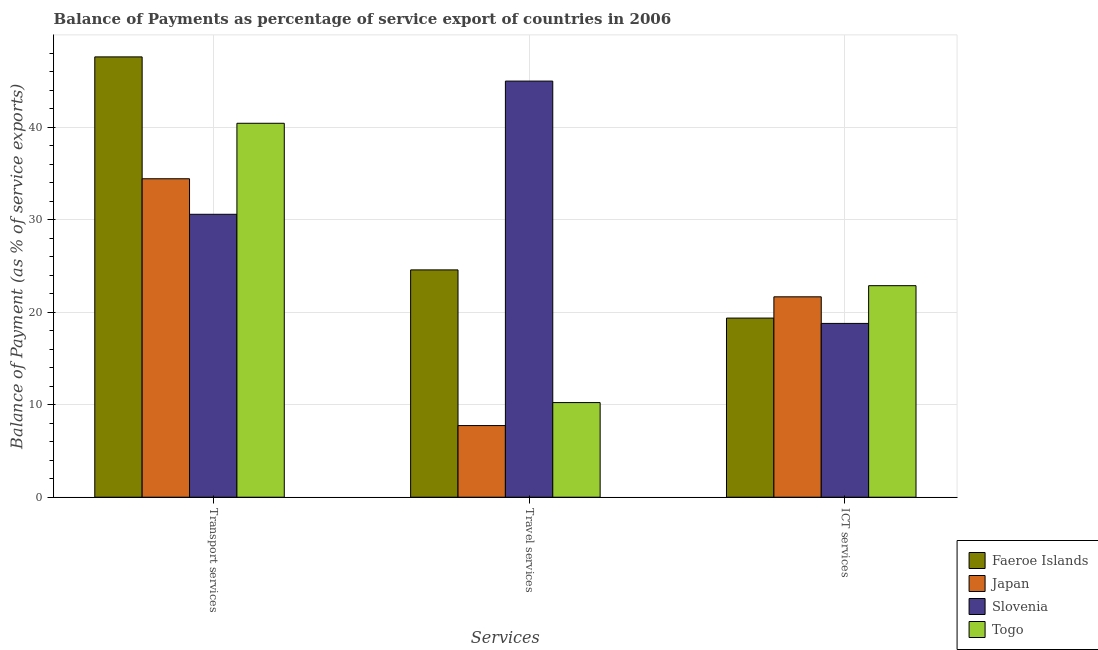How many groups of bars are there?
Your response must be concise. 3. Are the number of bars per tick equal to the number of legend labels?
Your answer should be compact. Yes. How many bars are there on the 1st tick from the left?
Keep it short and to the point. 4. How many bars are there on the 1st tick from the right?
Give a very brief answer. 4. What is the label of the 1st group of bars from the left?
Provide a succinct answer. Transport services. What is the balance of payment of ict services in Slovenia?
Your answer should be compact. 18.79. Across all countries, what is the maximum balance of payment of travel services?
Your answer should be very brief. 44.99. Across all countries, what is the minimum balance of payment of transport services?
Offer a very short reply. 30.59. In which country was the balance of payment of transport services maximum?
Your answer should be very brief. Faeroe Islands. What is the total balance of payment of travel services in the graph?
Give a very brief answer. 87.54. What is the difference between the balance of payment of ict services in Faeroe Islands and that in Slovenia?
Offer a terse response. 0.58. What is the difference between the balance of payment of travel services in Slovenia and the balance of payment of transport services in Japan?
Ensure brevity in your answer.  10.56. What is the average balance of payment of ict services per country?
Provide a short and direct response. 20.67. What is the difference between the balance of payment of ict services and balance of payment of transport services in Japan?
Your answer should be compact. -12.76. In how many countries, is the balance of payment of transport services greater than 36 %?
Your response must be concise. 2. What is the ratio of the balance of payment of travel services in Faeroe Islands to that in Slovenia?
Ensure brevity in your answer.  0.55. What is the difference between the highest and the second highest balance of payment of ict services?
Provide a short and direct response. 1.2. What is the difference between the highest and the lowest balance of payment of transport services?
Offer a terse response. 17.02. In how many countries, is the balance of payment of travel services greater than the average balance of payment of travel services taken over all countries?
Provide a succinct answer. 2. What does the 1st bar from the left in Travel services represents?
Your answer should be very brief. Faeroe Islands. What does the 4th bar from the right in Transport services represents?
Make the answer very short. Faeroe Islands. Are all the bars in the graph horizontal?
Give a very brief answer. No. What is the difference between two consecutive major ticks on the Y-axis?
Make the answer very short. 10. Does the graph contain any zero values?
Offer a terse response. No. Does the graph contain grids?
Offer a terse response. Yes. What is the title of the graph?
Provide a succinct answer. Balance of Payments as percentage of service export of countries in 2006. What is the label or title of the X-axis?
Your answer should be compact. Services. What is the label or title of the Y-axis?
Provide a succinct answer. Balance of Payment (as % of service exports). What is the Balance of Payment (as % of service exports) in Faeroe Islands in Transport services?
Provide a succinct answer. 47.61. What is the Balance of Payment (as % of service exports) in Japan in Transport services?
Provide a succinct answer. 34.43. What is the Balance of Payment (as % of service exports) of Slovenia in Transport services?
Give a very brief answer. 30.59. What is the Balance of Payment (as % of service exports) of Togo in Transport services?
Ensure brevity in your answer.  40.43. What is the Balance of Payment (as % of service exports) of Faeroe Islands in Travel services?
Your answer should be very brief. 24.58. What is the Balance of Payment (as % of service exports) in Japan in Travel services?
Your answer should be very brief. 7.75. What is the Balance of Payment (as % of service exports) in Slovenia in Travel services?
Your answer should be very brief. 44.99. What is the Balance of Payment (as % of service exports) in Togo in Travel services?
Your answer should be very brief. 10.23. What is the Balance of Payment (as % of service exports) of Faeroe Islands in ICT services?
Keep it short and to the point. 19.37. What is the Balance of Payment (as % of service exports) of Japan in ICT services?
Your answer should be very brief. 21.67. What is the Balance of Payment (as % of service exports) of Slovenia in ICT services?
Offer a very short reply. 18.79. What is the Balance of Payment (as % of service exports) of Togo in ICT services?
Keep it short and to the point. 22.87. Across all Services, what is the maximum Balance of Payment (as % of service exports) in Faeroe Islands?
Provide a short and direct response. 47.61. Across all Services, what is the maximum Balance of Payment (as % of service exports) of Japan?
Provide a short and direct response. 34.43. Across all Services, what is the maximum Balance of Payment (as % of service exports) of Slovenia?
Keep it short and to the point. 44.99. Across all Services, what is the maximum Balance of Payment (as % of service exports) of Togo?
Make the answer very short. 40.43. Across all Services, what is the minimum Balance of Payment (as % of service exports) of Faeroe Islands?
Your response must be concise. 19.37. Across all Services, what is the minimum Balance of Payment (as % of service exports) in Japan?
Your response must be concise. 7.75. Across all Services, what is the minimum Balance of Payment (as % of service exports) of Slovenia?
Your response must be concise. 18.79. Across all Services, what is the minimum Balance of Payment (as % of service exports) of Togo?
Your response must be concise. 10.23. What is the total Balance of Payment (as % of service exports) of Faeroe Islands in the graph?
Provide a short and direct response. 91.55. What is the total Balance of Payment (as % of service exports) of Japan in the graph?
Your answer should be very brief. 63.84. What is the total Balance of Payment (as % of service exports) of Slovenia in the graph?
Offer a very short reply. 94.37. What is the total Balance of Payment (as % of service exports) in Togo in the graph?
Provide a succinct answer. 73.53. What is the difference between the Balance of Payment (as % of service exports) in Faeroe Islands in Transport services and that in Travel services?
Keep it short and to the point. 23.03. What is the difference between the Balance of Payment (as % of service exports) in Japan in Transport services and that in Travel services?
Your response must be concise. 26.68. What is the difference between the Balance of Payment (as % of service exports) in Slovenia in Transport services and that in Travel services?
Your response must be concise. -14.4. What is the difference between the Balance of Payment (as % of service exports) of Togo in Transport services and that in Travel services?
Your answer should be very brief. 30.2. What is the difference between the Balance of Payment (as % of service exports) of Faeroe Islands in Transport services and that in ICT services?
Your answer should be very brief. 28.24. What is the difference between the Balance of Payment (as % of service exports) of Japan in Transport services and that in ICT services?
Ensure brevity in your answer.  12.76. What is the difference between the Balance of Payment (as % of service exports) of Slovenia in Transport services and that in ICT services?
Your answer should be very brief. 11.8. What is the difference between the Balance of Payment (as % of service exports) in Togo in Transport services and that in ICT services?
Your answer should be very brief. 17.56. What is the difference between the Balance of Payment (as % of service exports) in Faeroe Islands in Travel services and that in ICT services?
Provide a succinct answer. 5.21. What is the difference between the Balance of Payment (as % of service exports) of Japan in Travel services and that in ICT services?
Offer a very short reply. -13.92. What is the difference between the Balance of Payment (as % of service exports) of Slovenia in Travel services and that in ICT services?
Provide a succinct answer. 26.2. What is the difference between the Balance of Payment (as % of service exports) of Togo in Travel services and that in ICT services?
Your answer should be very brief. -12.64. What is the difference between the Balance of Payment (as % of service exports) of Faeroe Islands in Transport services and the Balance of Payment (as % of service exports) of Japan in Travel services?
Make the answer very short. 39.86. What is the difference between the Balance of Payment (as % of service exports) of Faeroe Islands in Transport services and the Balance of Payment (as % of service exports) of Slovenia in Travel services?
Your response must be concise. 2.62. What is the difference between the Balance of Payment (as % of service exports) in Faeroe Islands in Transport services and the Balance of Payment (as % of service exports) in Togo in Travel services?
Offer a terse response. 37.38. What is the difference between the Balance of Payment (as % of service exports) in Japan in Transport services and the Balance of Payment (as % of service exports) in Slovenia in Travel services?
Keep it short and to the point. -10.56. What is the difference between the Balance of Payment (as % of service exports) of Japan in Transport services and the Balance of Payment (as % of service exports) of Togo in Travel services?
Provide a short and direct response. 24.2. What is the difference between the Balance of Payment (as % of service exports) in Slovenia in Transport services and the Balance of Payment (as % of service exports) in Togo in Travel services?
Give a very brief answer. 20.36. What is the difference between the Balance of Payment (as % of service exports) of Faeroe Islands in Transport services and the Balance of Payment (as % of service exports) of Japan in ICT services?
Offer a terse response. 25.94. What is the difference between the Balance of Payment (as % of service exports) in Faeroe Islands in Transport services and the Balance of Payment (as % of service exports) in Slovenia in ICT services?
Give a very brief answer. 28.82. What is the difference between the Balance of Payment (as % of service exports) in Faeroe Islands in Transport services and the Balance of Payment (as % of service exports) in Togo in ICT services?
Offer a terse response. 24.73. What is the difference between the Balance of Payment (as % of service exports) of Japan in Transport services and the Balance of Payment (as % of service exports) of Slovenia in ICT services?
Provide a succinct answer. 15.64. What is the difference between the Balance of Payment (as % of service exports) in Japan in Transport services and the Balance of Payment (as % of service exports) in Togo in ICT services?
Offer a terse response. 11.56. What is the difference between the Balance of Payment (as % of service exports) of Slovenia in Transport services and the Balance of Payment (as % of service exports) of Togo in ICT services?
Make the answer very short. 7.72. What is the difference between the Balance of Payment (as % of service exports) of Faeroe Islands in Travel services and the Balance of Payment (as % of service exports) of Japan in ICT services?
Your answer should be very brief. 2.91. What is the difference between the Balance of Payment (as % of service exports) in Faeroe Islands in Travel services and the Balance of Payment (as % of service exports) in Slovenia in ICT services?
Your response must be concise. 5.79. What is the difference between the Balance of Payment (as % of service exports) of Faeroe Islands in Travel services and the Balance of Payment (as % of service exports) of Togo in ICT services?
Give a very brief answer. 1.71. What is the difference between the Balance of Payment (as % of service exports) in Japan in Travel services and the Balance of Payment (as % of service exports) in Slovenia in ICT services?
Provide a short and direct response. -11.04. What is the difference between the Balance of Payment (as % of service exports) of Japan in Travel services and the Balance of Payment (as % of service exports) of Togo in ICT services?
Offer a very short reply. -15.13. What is the difference between the Balance of Payment (as % of service exports) of Slovenia in Travel services and the Balance of Payment (as % of service exports) of Togo in ICT services?
Offer a terse response. 22.12. What is the average Balance of Payment (as % of service exports) in Faeroe Islands per Services?
Provide a succinct answer. 30.52. What is the average Balance of Payment (as % of service exports) of Japan per Services?
Offer a terse response. 21.28. What is the average Balance of Payment (as % of service exports) of Slovenia per Services?
Your answer should be very brief. 31.46. What is the average Balance of Payment (as % of service exports) of Togo per Services?
Give a very brief answer. 24.51. What is the difference between the Balance of Payment (as % of service exports) of Faeroe Islands and Balance of Payment (as % of service exports) of Japan in Transport services?
Offer a terse response. 13.18. What is the difference between the Balance of Payment (as % of service exports) of Faeroe Islands and Balance of Payment (as % of service exports) of Slovenia in Transport services?
Keep it short and to the point. 17.02. What is the difference between the Balance of Payment (as % of service exports) in Faeroe Islands and Balance of Payment (as % of service exports) in Togo in Transport services?
Provide a succinct answer. 7.18. What is the difference between the Balance of Payment (as % of service exports) in Japan and Balance of Payment (as % of service exports) in Slovenia in Transport services?
Ensure brevity in your answer.  3.84. What is the difference between the Balance of Payment (as % of service exports) of Japan and Balance of Payment (as % of service exports) of Togo in Transport services?
Your response must be concise. -6. What is the difference between the Balance of Payment (as % of service exports) of Slovenia and Balance of Payment (as % of service exports) of Togo in Transport services?
Ensure brevity in your answer.  -9.84. What is the difference between the Balance of Payment (as % of service exports) of Faeroe Islands and Balance of Payment (as % of service exports) of Japan in Travel services?
Your answer should be very brief. 16.83. What is the difference between the Balance of Payment (as % of service exports) in Faeroe Islands and Balance of Payment (as % of service exports) in Slovenia in Travel services?
Ensure brevity in your answer.  -20.41. What is the difference between the Balance of Payment (as % of service exports) in Faeroe Islands and Balance of Payment (as % of service exports) in Togo in Travel services?
Ensure brevity in your answer.  14.35. What is the difference between the Balance of Payment (as % of service exports) in Japan and Balance of Payment (as % of service exports) in Slovenia in Travel services?
Your response must be concise. -37.24. What is the difference between the Balance of Payment (as % of service exports) in Japan and Balance of Payment (as % of service exports) in Togo in Travel services?
Ensure brevity in your answer.  -2.48. What is the difference between the Balance of Payment (as % of service exports) in Slovenia and Balance of Payment (as % of service exports) in Togo in Travel services?
Your response must be concise. 34.76. What is the difference between the Balance of Payment (as % of service exports) in Faeroe Islands and Balance of Payment (as % of service exports) in Japan in ICT services?
Offer a terse response. -2.3. What is the difference between the Balance of Payment (as % of service exports) of Faeroe Islands and Balance of Payment (as % of service exports) of Slovenia in ICT services?
Provide a succinct answer. 0.58. What is the difference between the Balance of Payment (as % of service exports) of Faeroe Islands and Balance of Payment (as % of service exports) of Togo in ICT services?
Keep it short and to the point. -3.5. What is the difference between the Balance of Payment (as % of service exports) of Japan and Balance of Payment (as % of service exports) of Slovenia in ICT services?
Make the answer very short. 2.88. What is the difference between the Balance of Payment (as % of service exports) in Japan and Balance of Payment (as % of service exports) in Togo in ICT services?
Provide a short and direct response. -1.2. What is the difference between the Balance of Payment (as % of service exports) of Slovenia and Balance of Payment (as % of service exports) of Togo in ICT services?
Provide a succinct answer. -4.08. What is the ratio of the Balance of Payment (as % of service exports) of Faeroe Islands in Transport services to that in Travel services?
Offer a terse response. 1.94. What is the ratio of the Balance of Payment (as % of service exports) of Japan in Transport services to that in Travel services?
Offer a very short reply. 4.44. What is the ratio of the Balance of Payment (as % of service exports) of Slovenia in Transport services to that in Travel services?
Make the answer very short. 0.68. What is the ratio of the Balance of Payment (as % of service exports) in Togo in Transport services to that in Travel services?
Make the answer very short. 3.95. What is the ratio of the Balance of Payment (as % of service exports) in Faeroe Islands in Transport services to that in ICT services?
Your response must be concise. 2.46. What is the ratio of the Balance of Payment (as % of service exports) of Japan in Transport services to that in ICT services?
Provide a short and direct response. 1.59. What is the ratio of the Balance of Payment (as % of service exports) in Slovenia in Transport services to that in ICT services?
Your answer should be compact. 1.63. What is the ratio of the Balance of Payment (as % of service exports) of Togo in Transport services to that in ICT services?
Provide a succinct answer. 1.77. What is the ratio of the Balance of Payment (as % of service exports) of Faeroe Islands in Travel services to that in ICT services?
Keep it short and to the point. 1.27. What is the ratio of the Balance of Payment (as % of service exports) of Japan in Travel services to that in ICT services?
Offer a terse response. 0.36. What is the ratio of the Balance of Payment (as % of service exports) in Slovenia in Travel services to that in ICT services?
Your response must be concise. 2.39. What is the ratio of the Balance of Payment (as % of service exports) in Togo in Travel services to that in ICT services?
Offer a very short reply. 0.45. What is the difference between the highest and the second highest Balance of Payment (as % of service exports) in Faeroe Islands?
Offer a very short reply. 23.03. What is the difference between the highest and the second highest Balance of Payment (as % of service exports) of Japan?
Offer a terse response. 12.76. What is the difference between the highest and the second highest Balance of Payment (as % of service exports) of Slovenia?
Ensure brevity in your answer.  14.4. What is the difference between the highest and the second highest Balance of Payment (as % of service exports) of Togo?
Ensure brevity in your answer.  17.56. What is the difference between the highest and the lowest Balance of Payment (as % of service exports) in Faeroe Islands?
Keep it short and to the point. 28.24. What is the difference between the highest and the lowest Balance of Payment (as % of service exports) of Japan?
Provide a succinct answer. 26.68. What is the difference between the highest and the lowest Balance of Payment (as % of service exports) of Slovenia?
Ensure brevity in your answer.  26.2. What is the difference between the highest and the lowest Balance of Payment (as % of service exports) of Togo?
Make the answer very short. 30.2. 